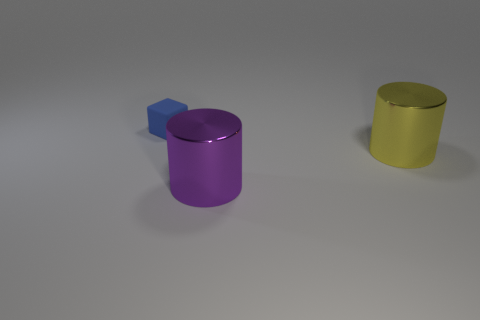Add 1 shiny cylinders. How many objects exist? 4 Subtract all cylinders. How many objects are left? 1 Subtract all yellow cylinders. How many cylinders are left? 1 Subtract 2 cylinders. How many cylinders are left? 0 Subtract all brown cylinders. Subtract all purple cubes. How many cylinders are left? 2 Subtract all cyan balls. How many yellow cylinders are left? 1 Subtract all tiny rubber objects. Subtract all yellow things. How many objects are left? 1 Add 2 large yellow objects. How many large yellow objects are left? 3 Add 3 matte cubes. How many matte cubes exist? 4 Subtract 0 gray balls. How many objects are left? 3 